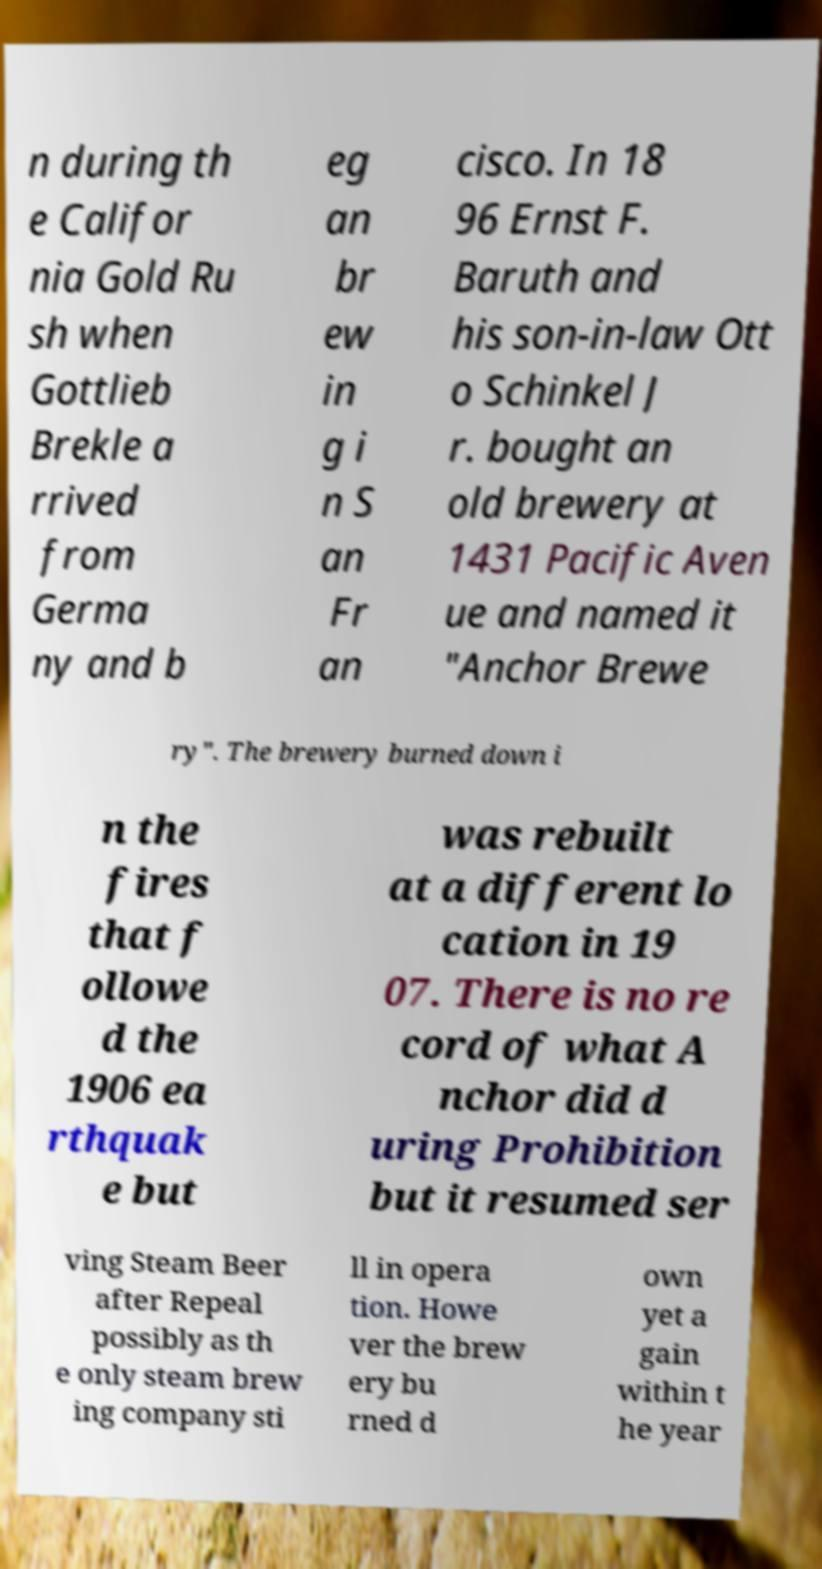I need the written content from this picture converted into text. Can you do that? n during th e Califor nia Gold Ru sh when Gottlieb Brekle a rrived from Germa ny and b eg an br ew in g i n S an Fr an cisco. In 18 96 Ernst F. Baruth and his son-in-law Ott o Schinkel J r. bought an old brewery at 1431 Pacific Aven ue and named it "Anchor Brewe ry". The brewery burned down i n the fires that f ollowe d the 1906 ea rthquak e but was rebuilt at a different lo cation in 19 07. There is no re cord of what A nchor did d uring Prohibition but it resumed ser ving Steam Beer after Repeal possibly as th e only steam brew ing company sti ll in opera tion. Howe ver the brew ery bu rned d own yet a gain within t he year 